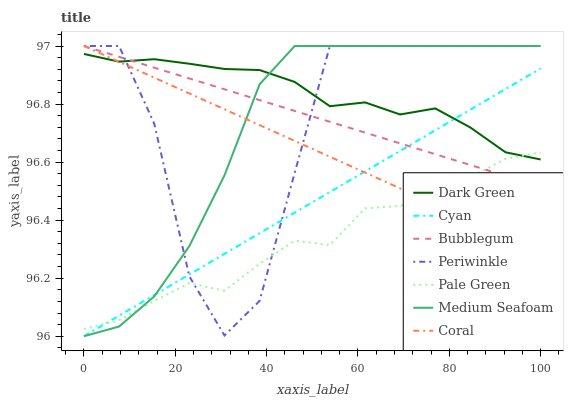Does Bubblegum have the minimum area under the curve?
Answer yes or no. No. Does Bubblegum have the maximum area under the curve?
Answer yes or no. No. Is Bubblegum the smoothest?
Answer yes or no. No. Is Bubblegum the roughest?
Answer yes or no. No. Does Bubblegum have the lowest value?
Answer yes or no. No. Does Pale Green have the highest value?
Answer yes or no. No. 